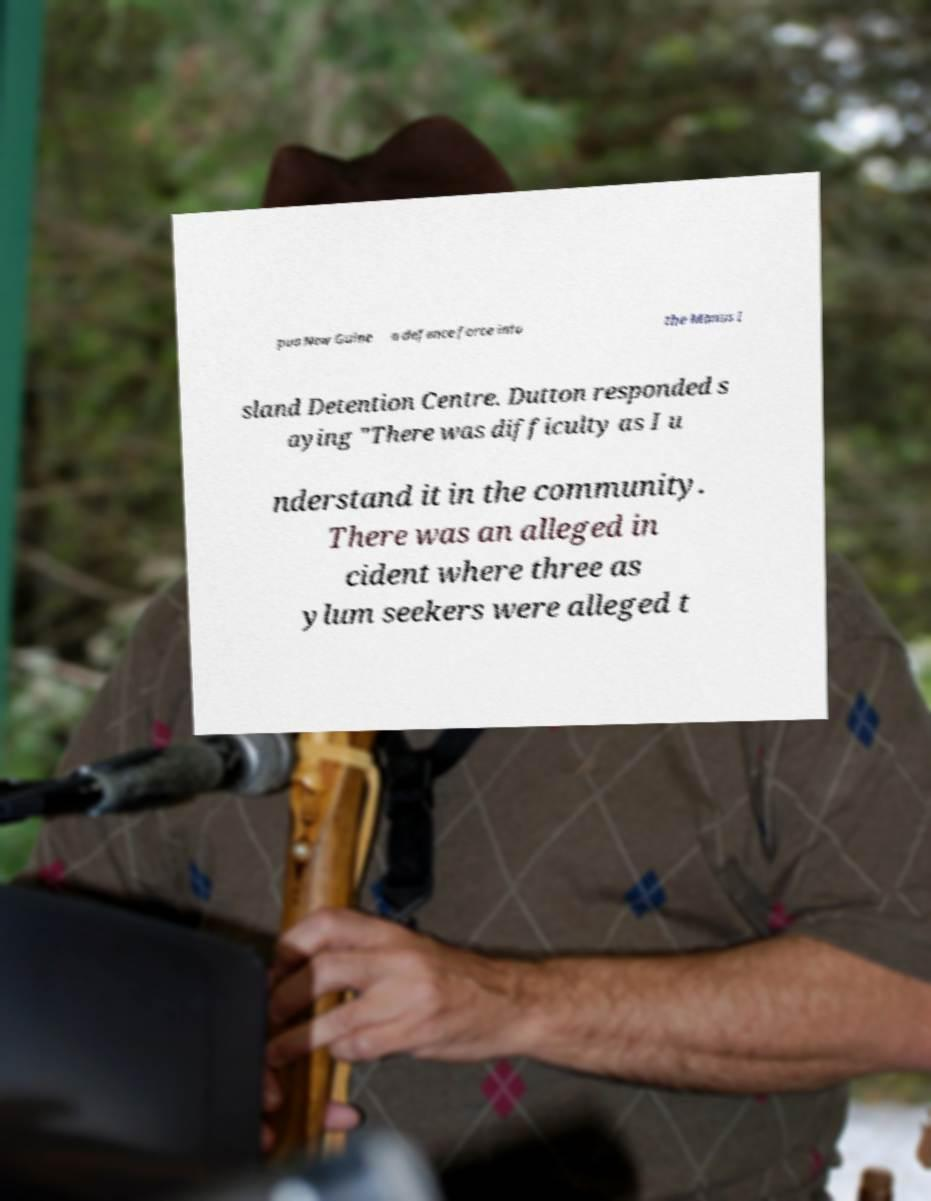Can you accurately transcribe the text from the provided image for me? pua New Guine a defence force into the Manus I sland Detention Centre. Dutton responded s aying "There was difficulty as I u nderstand it in the community. There was an alleged in cident where three as ylum seekers were alleged t 